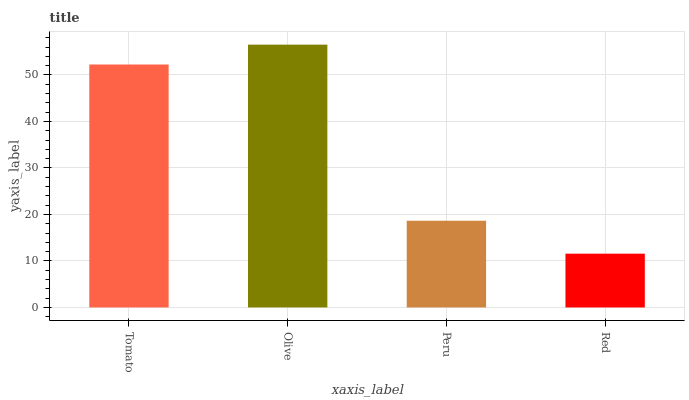Is Red the minimum?
Answer yes or no. Yes. Is Olive the maximum?
Answer yes or no. Yes. Is Peru the minimum?
Answer yes or no. No. Is Peru the maximum?
Answer yes or no. No. Is Olive greater than Peru?
Answer yes or no. Yes. Is Peru less than Olive?
Answer yes or no. Yes. Is Peru greater than Olive?
Answer yes or no. No. Is Olive less than Peru?
Answer yes or no. No. Is Tomato the high median?
Answer yes or no. Yes. Is Peru the low median?
Answer yes or no. Yes. Is Olive the high median?
Answer yes or no. No. Is Red the low median?
Answer yes or no. No. 